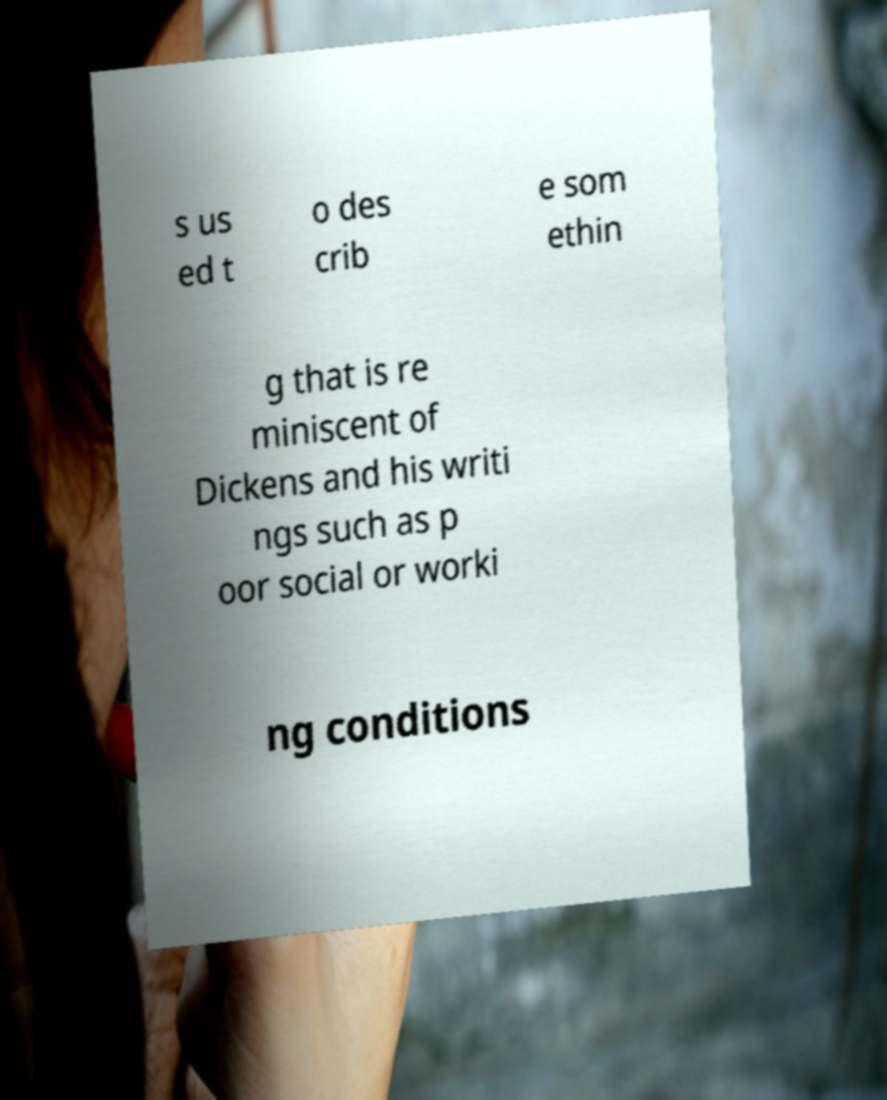Could you extract and type out the text from this image? s us ed t o des crib e som ethin g that is re miniscent of Dickens and his writi ngs such as p oor social or worki ng conditions 